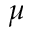Convert formula to latex. <formula><loc_0><loc_0><loc_500><loc_500>\mu</formula> 